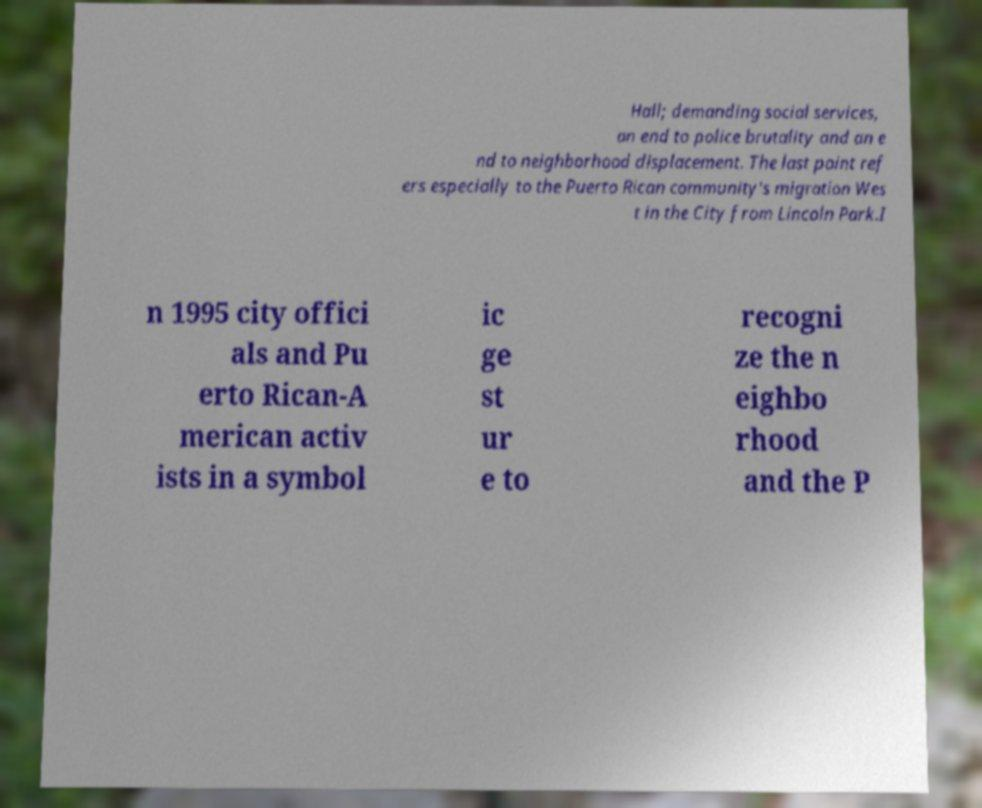Can you read and provide the text displayed in the image?This photo seems to have some interesting text. Can you extract and type it out for me? Hall; demanding social services, an end to police brutality and an e nd to neighborhood displacement. The last point ref ers especially to the Puerto Rican community's migration Wes t in the City from Lincoln Park.I n 1995 city offici als and Pu erto Rican-A merican activ ists in a symbol ic ge st ur e to recogni ze the n eighbo rhood and the P 